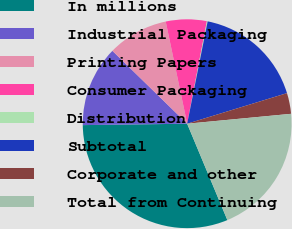<chart> <loc_0><loc_0><loc_500><loc_500><pie_chart><fcel>In millions<fcel>Industrial Packaging<fcel>Printing Papers<fcel>Consumer Packaging<fcel>Distribution<fcel>Subtotal<fcel>Corporate and other<fcel>Total from Continuing<nl><fcel>31.08%<fcel>12.51%<fcel>9.41%<fcel>6.32%<fcel>0.12%<fcel>17.12%<fcel>3.22%<fcel>20.22%<nl></chart> 